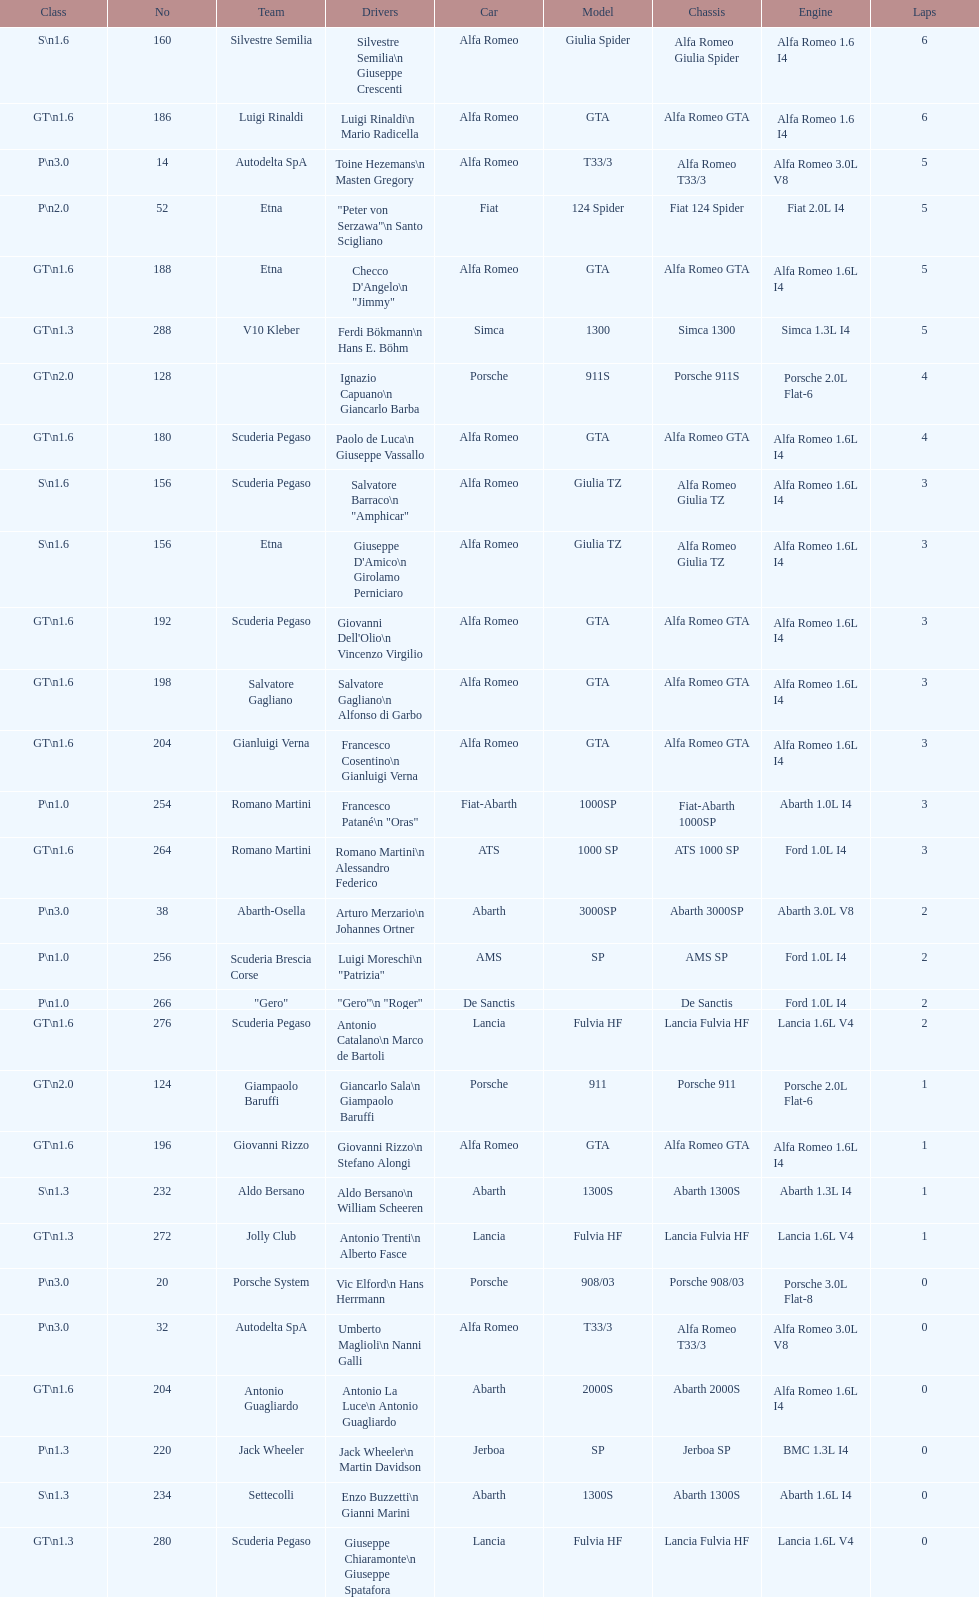6? GT 1.6. 